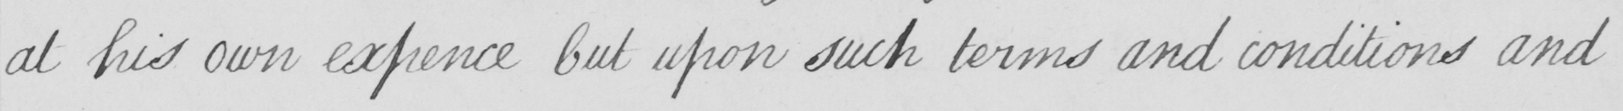Transcribe the text shown in this historical manuscript line. at his own expence but upon such terms and conditions and 